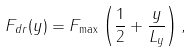Convert formula to latex. <formula><loc_0><loc_0><loc_500><loc_500>F _ { d r } ( y ) = F _ { \max } \left ( \frac { 1 } { 2 } + \frac { y } { L _ { y } } \right ) ,</formula> 